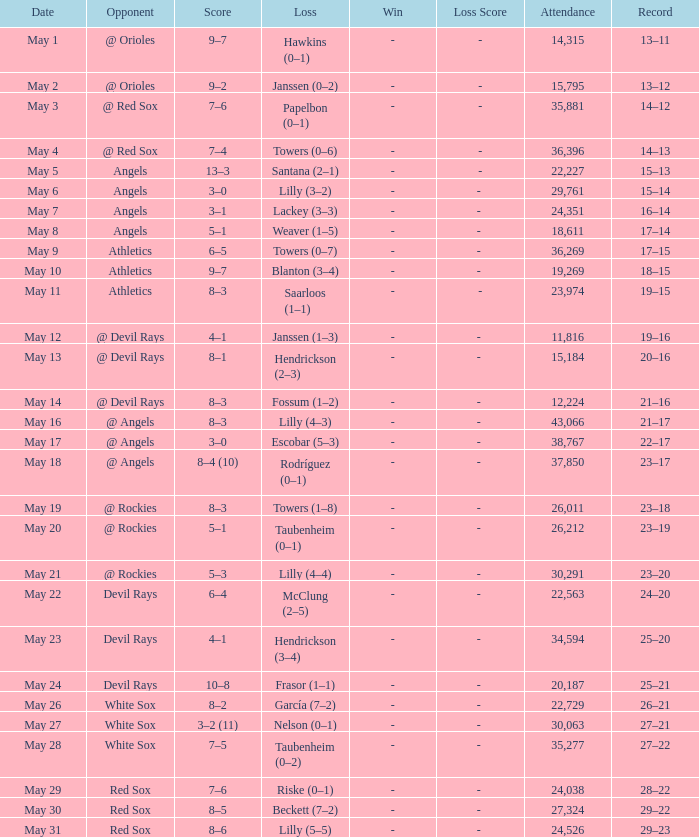What was the mean attendance for matches with a defeat of papelbon (0–1)? 35881.0. 